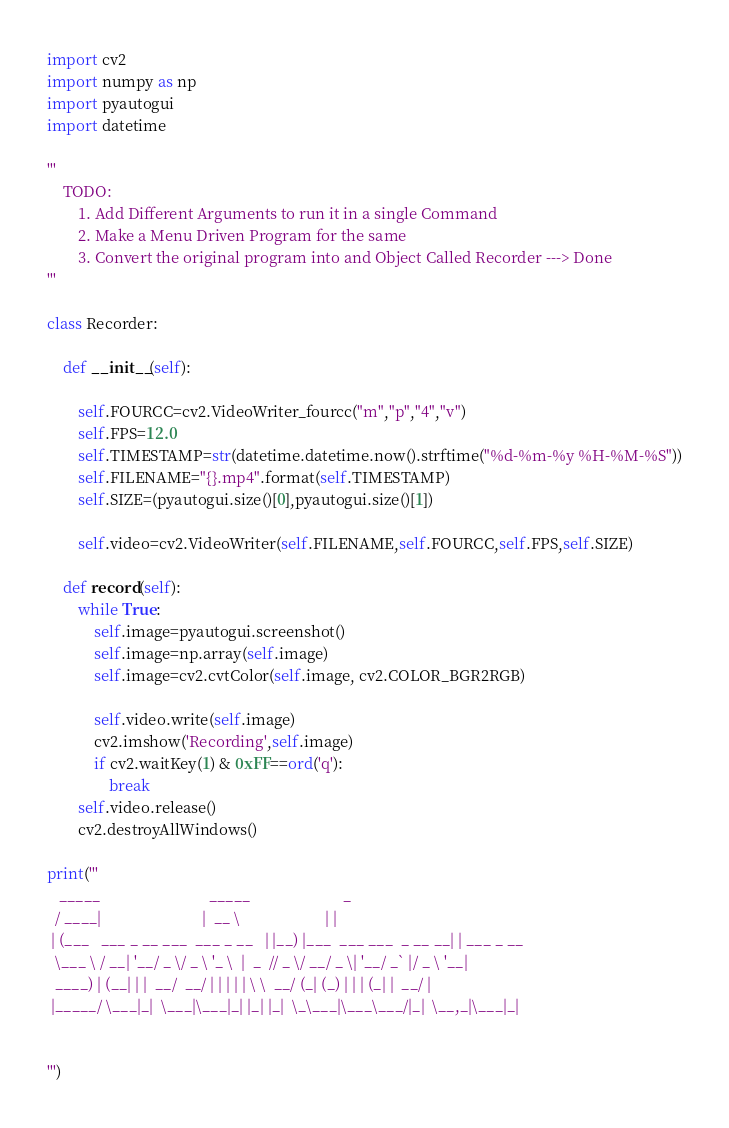<code> <loc_0><loc_0><loc_500><loc_500><_Python_>import cv2
import numpy as np
import pyautogui
import datetime

'''
    TODO:
        1. Add Different Arguments to run it in a single Command
        2. Make a Menu Driven Program for the same
        3. Convert the original program into and Object Called Recorder ---> Done
'''

class Recorder:

    def __init__(self):

        self.FOURCC=cv2.VideoWriter_fourcc("m","p","4","v")
        self.FPS=12.0
        self.TIMESTAMP=str(datetime.datetime.now().strftime("%d-%m-%y %H-%M-%S"))
        self.FILENAME="{}.mp4".format(self.TIMESTAMP)
        self.SIZE=(pyautogui.size()[0],pyautogui.size()[1])

        self.video=cv2.VideoWriter(self.FILENAME,self.FOURCC,self.FPS,self.SIZE)

    def record(self):
        while True:
            self.image=pyautogui.screenshot()
            self.image=np.array(self.image)
            self.image=cv2.cvtColor(self.image, cv2.COLOR_BGR2RGB)

            self.video.write(self.image)
            cv2.imshow('Recording',self.image)
            if cv2.waitKey(1) & 0xFF==ord('q'):
                break
        self.video.release()
        cv2.destroyAllWindows()

print('''
   _____                            _____                        _           
  / ____|                          |  __ \                      | |          
 | (___   ___ _ __ ___  ___ _ __   | |__) |___  ___ ___  _ __ __| | ___ _ __ 
  \___ \ / __| '__/ _ \/ _ \ '_ \  |  _  // _ \/ __/ _ \| '__/ _` |/ _ \ '__|
  ____) | (__| | |  __/  __/ | | | | | \ \  __/ (_| (_) | | | (_| |  __/ |   
 |_____/ \___|_|  \___|\___|_| |_| |_|  \_\___|\___\___/|_|  \__,_|\___|_|   
                                                                             
                                                                             
''')


</code> 